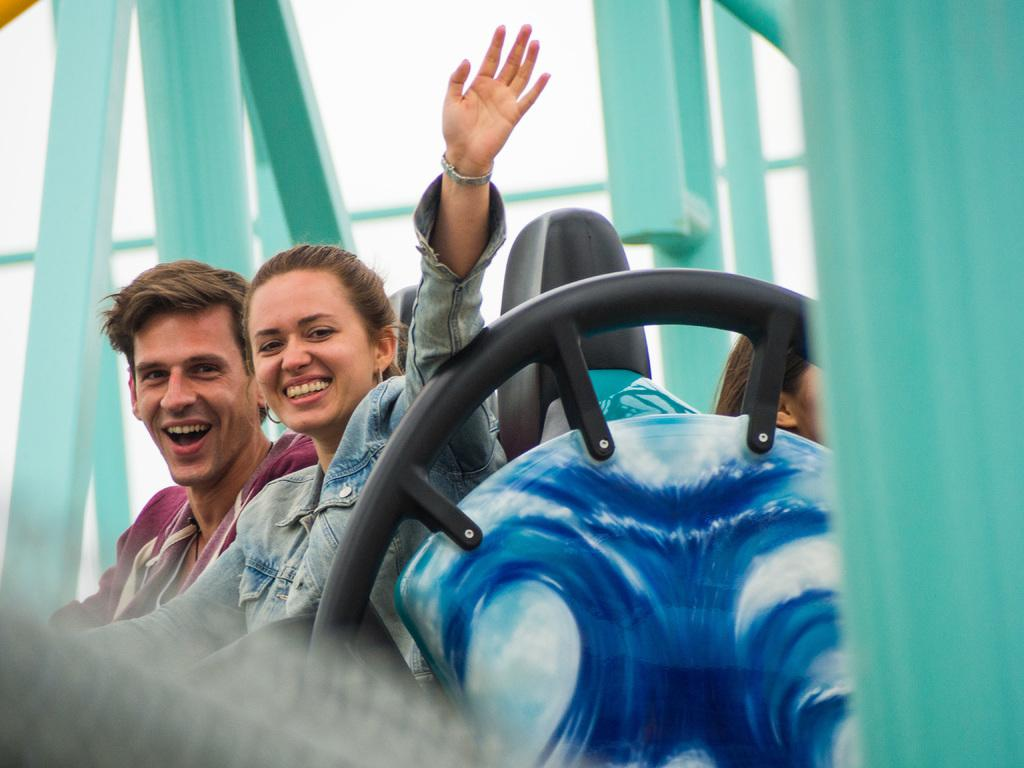Who are the people in the picture? There is a boy, a girl, and a woman in the picture. What are the boy and girl doing in the picture? The boy and girl are taking a ride. What is the woman doing in the picture? The woman is waving her hand and smiling. What type of paste is the boy using to achieve a better grip on the ride? There is no paste present in the image, and the boy is not shown using any substance to improve his grip. 